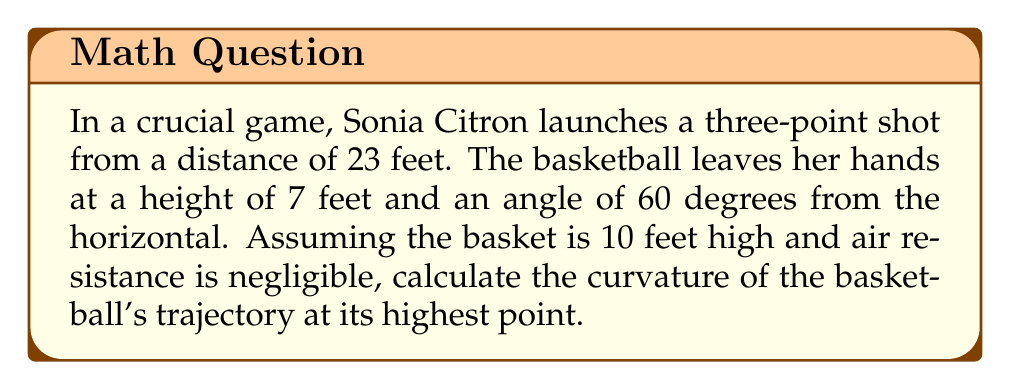Give your solution to this math problem. Let's approach this step-by-step:

1) First, we need to set up a coordinate system. Let's use the x-axis for horizontal distance and the y-axis for height.

2) The trajectory of the basketball follows a parabolic path, which can be described by the equation:

   $$y = ax^2 + bx + c$$

3) To find the coefficients a, b, and c, we can use the initial conditions:
   - Initial height: $y(0) = 7$
   - Final height: $y(23) = 10$
   - Initial angle: $\tan(60°) = \frac{dy}{dx}|_{x=0} = b$

4) From these conditions:
   $$c = 7$$
   $$b = \tan(60°) = \sqrt{3}$$
   $$10 = a(23)^2 + \sqrt{3}(23) + 7$$

5) Solving for a:
   $$a = \frac{10 - \sqrt{3}(23) - 7}{(23)^2} \approx -0.0163$$

6) Now we have the equation of the trajectory:
   $$y = -0.0163x^2 + \sqrt{3}x + 7$$

7) The curvature $\kappa$ of a curve $y=f(x)$ at any point is given by:

   $$\kappa = \frac{|f''(x)|}{(1 + (f'(x))^2)^{3/2}}$$

8) For our parabola:
   $$f'(x) = -0.0326x + \sqrt{3}$$
   $$f''(x) = -0.0326$$

9) The highest point occurs where $f'(x) = 0$:
   $$-0.0326x + \sqrt{3} = 0$$
   $$x = \frac{\sqrt{3}}{0.0326} \approx 53.1 \text{ feet}$$

10) At this point, $f'(x) = 0$, so the curvature simplifies to:
    $$\kappa = |f''(x)| = 0.0326$$

Therefore, the curvature at the highest point of the trajectory is 0.0326 ft^(-1).
Answer: $0.0326 \text{ ft}^{-1}$ 